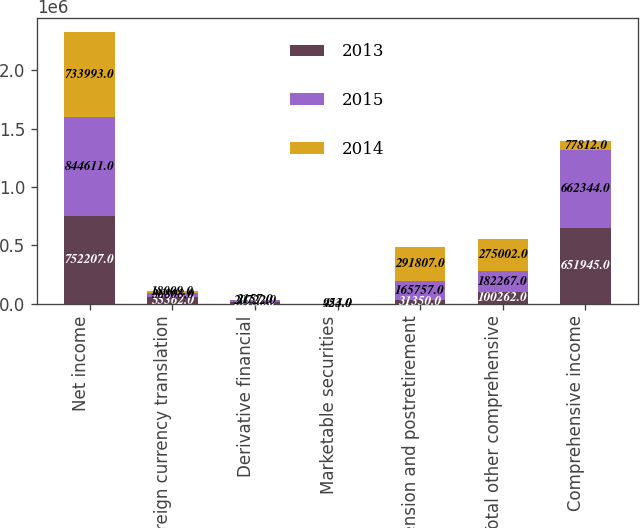Convert chart to OTSL. <chart><loc_0><loc_0><loc_500><loc_500><stacked_bar_chart><ecel><fcel>Net income<fcel>Foreign currency translation<fcel>Derivative financial<fcel>Marketable securities<fcel>Pension and postretirement<fcel>Total other comprehensive<fcel>Comprehensive income<nl><fcel>2013<fcel>752207<fcel>55362<fcel>13156<fcel>394<fcel>31350<fcel>100262<fcel>651945<nl><fcel>2015<fcel>844611<fcel>36808<fcel>20722<fcel>424<fcel>165757<fcel>182267<fcel>662344<nl><fcel>2014<fcel>733993<fcel>18009<fcel>2157<fcel>953<fcel>291807<fcel>275002<fcel>77812<nl></chart> 